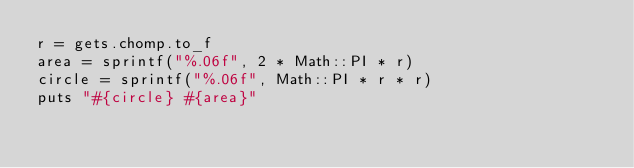<code> <loc_0><loc_0><loc_500><loc_500><_Ruby_>r = gets.chomp.to_f
area = sprintf("%.06f", 2 * Math::PI * r)
circle = sprintf("%.06f", Math::PI * r * r)
puts "#{circle} #{area}"

</code> 